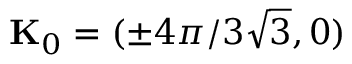Convert formula to latex. <formula><loc_0><loc_0><loc_500><loc_500>K _ { 0 } = ( \pm 4 \pi / 3 \sqrt { 3 } , 0 )</formula> 